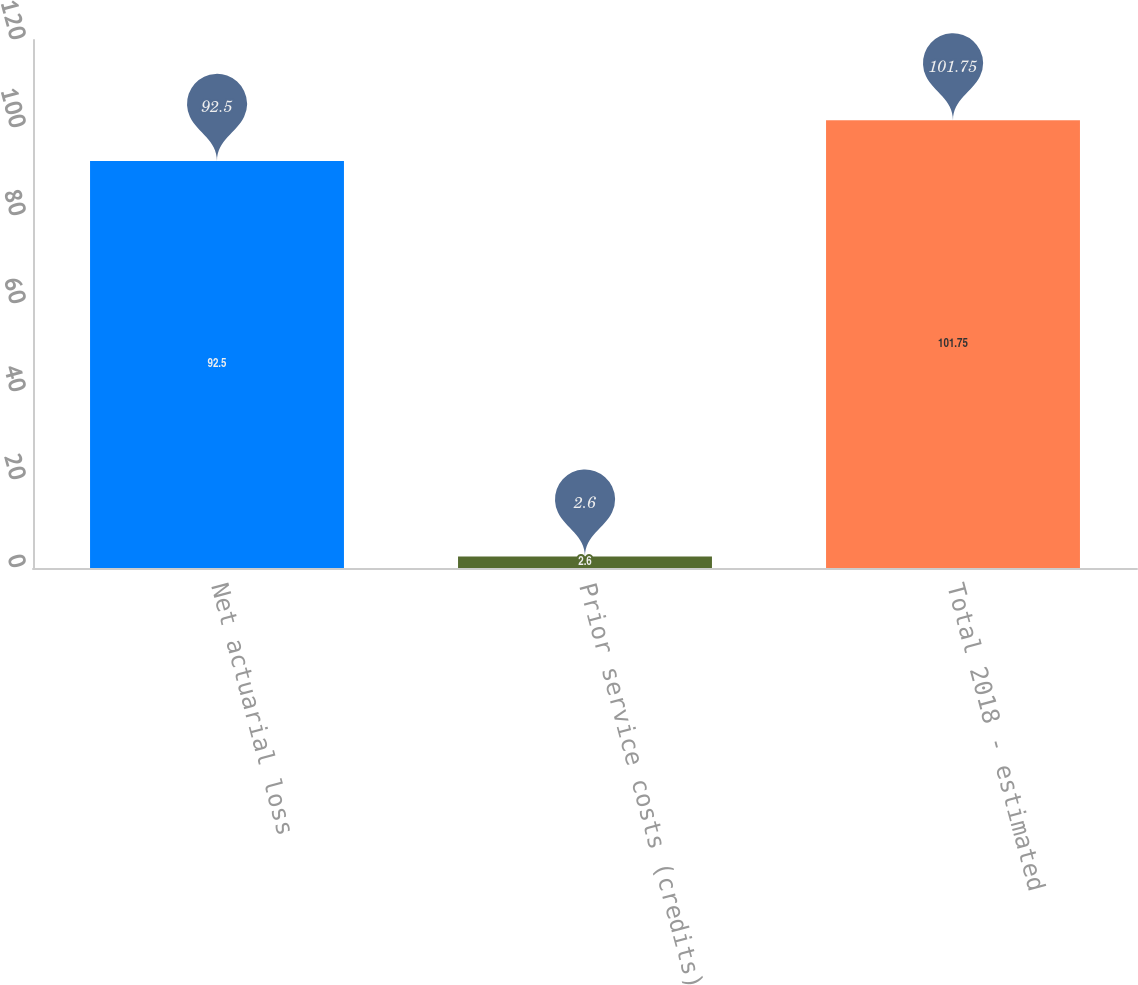Convert chart to OTSL. <chart><loc_0><loc_0><loc_500><loc_500><bar_chart><fcel>Net actuarial loss<fcel>Prior service costs (credits)<fcel>Total 2018 - estimated<nl><fcel>92.5<fcel>2.6<fcel>101.75<nl></chart> 